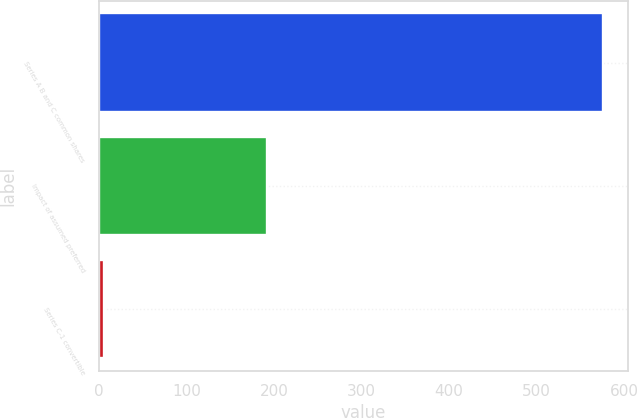Convert chart. <chart><loc_0><loc_0><loc_500><loc_500><bar_chart><fcel>Series A B and C common shares<fcel>Impact of assumed preferred<fcel>Series C-1 convertible<nl><fcel>576<fcel>192<fcel>6<nl></chart> 